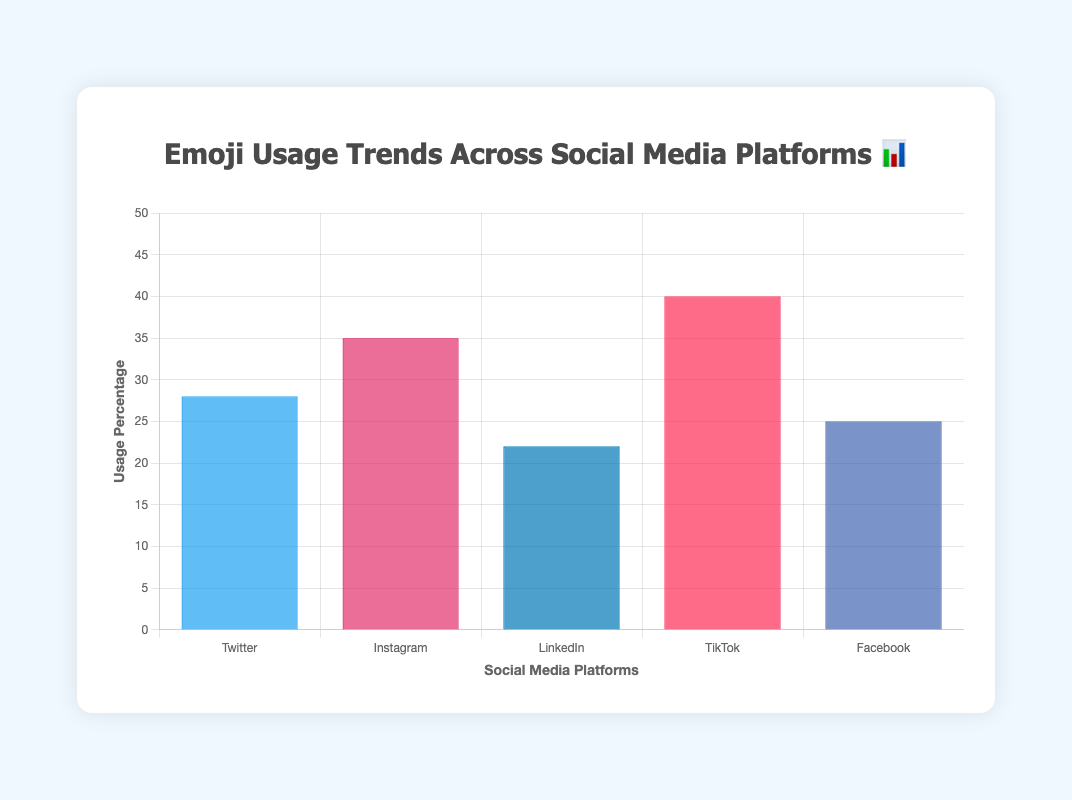What's the title of the chart? The title is written at the top of the chart. It reads, "Emoji Usage Trends Across Social Media Platforms 📊."
Answer: Emoji Usage Trends Across Social Media Platforms 📊 Which social media platform has the highest emoji usage percentage? By looking at the height of the bars, the bar for TikTok is the highest, indicating the highest usage percentage.
Answer: TikTok What is the emoji associated with Twitter in this chart? The legend provided in the tooltips shows that each bar represents a different emoji. For Twitter, the tooltip shows "😂."
Answer: 😂 What's the average emoji usage percentage across all the platforms? Add the percentages for all platforms (28 + 35 + 22 + 40 + 25 = 150), and divide by the number of platforms (150 / 5).
Answer: 30 Which platform shows the second highest emoji usage and what is its percentage? Instagram's bar is the second highest after TikTok, indicating the second highest usage percentage. The height of the bar tells us the exact percentage, which is 35%.
Answer: Instagram, 35% How does the emoji usage percentage of LinkedIn compare to Facebook? Check the bar heights for both platforms. LinkedIn's bar is slightly shorter than Facebook's, meaning LinkedIn has a lower percentage (22%) compared to Facebook (25%).
Answer: LinkedIn is 3% lower than Facebook Which platforms have an emoji usage percentage above 30%? By looking at the bars, those for Instagram (35%) and TikTok (40%) are above 30%.
Answer: Instagram and TikTok What is the total emoji usage percentage of all platforms combined? Add the percentages for all platforms (28 + 35 + 22 + 40 + 25).
Answer: 150 Which emoji is used the least frequently in social media platforms? By comparing the bar heights, LinkedIn has the smallest bar, indicating its emoji (👍) is used the least frequently at 22%.
Answer: 👍 If TikTok's emoji usage grew by 5%, what would the new usage percentage be? TikTok's current usage is 40%. If it grows by 5%, add 5 to 40 (40 + 5 = 45).
Answer: 45 